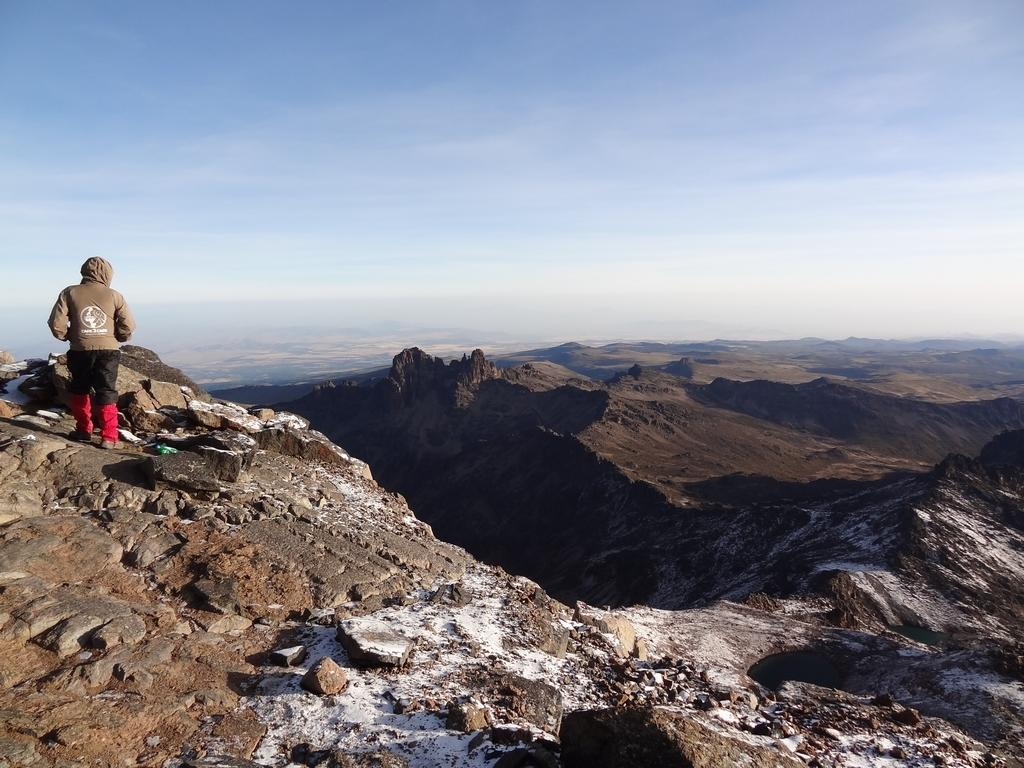What is located on the left side of the image? There is a person standing on the left side of the image. What can be seen on the ground in the image? There are stones on the ground in the image. What type of natural formation is visible in the background of the image? There are mountains visible in the background of the image. What color is the sky in the image? The sky is blue in color. What type of office can be seen in the image? There is no office present in the image; it features a person standing near stones with mountains in the background and a blue sky. How many geese are visible in the image? There are no geese present in the image. 